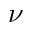Convert formula to latex. <formula><loc_0><loc_0><loc_500><loc_500>\nu</formula> 